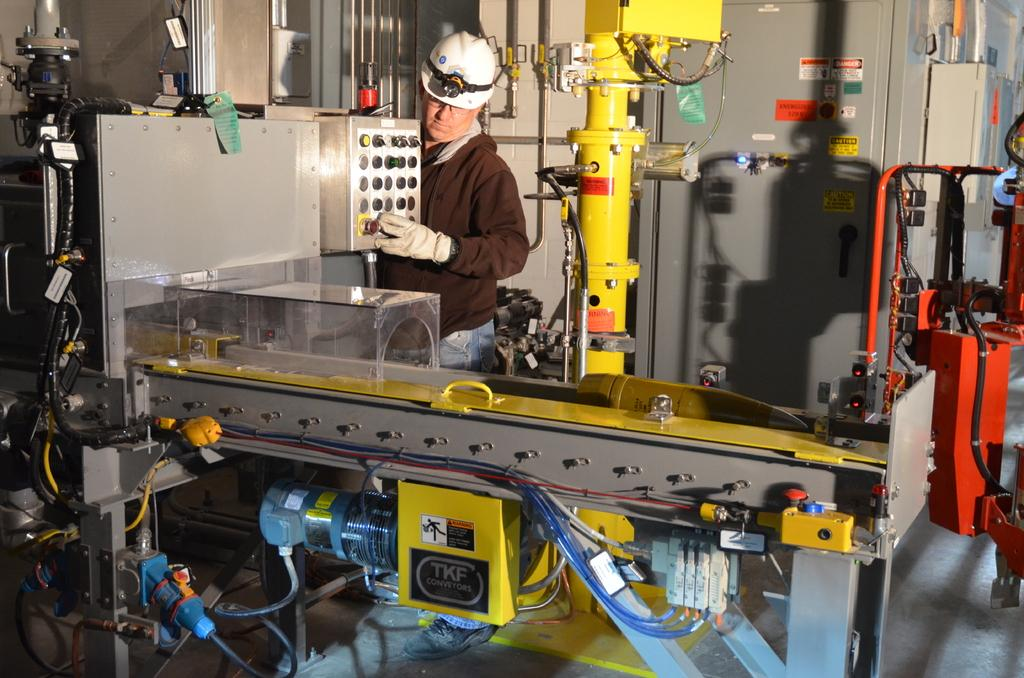Who or what is present in the image? There is a person in the image. What is the person wearing on their head? The person is wearing a white helmet. What can be seen in front of the person? There is a machine visible in front of the person. What is located at the top of the image? There is a wall at the top of the image. What type of vegetable is being cooked in the pan in the image? There is no pan or vegetable present in the image. 